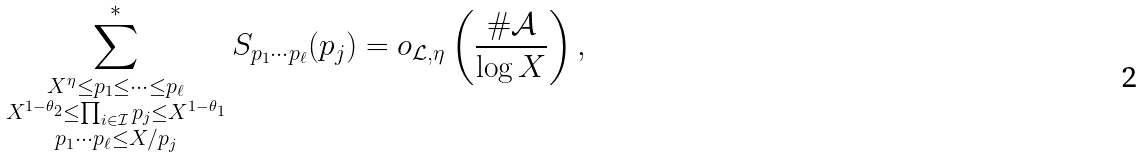<formula> <loc_0><loc_0><loc_500><loc_500>\sum _ { \substack { X ^ { \eta } \leq p _ { 1 } \leq \dots \leq p _ { \ell } \\ X ^ { 1 - \theta _ { 2 } } \leq \prod _ { i \in \mathcal { I } } p _ { j } \leq X ^ { 1 - \theta _ { 1 } } \\ p _ { 1 } \cdots p _ { \ell } \leq X / p _ { j } } } ^ { * } S _ { p _ { 1 } \cdots p _ { \ell } } ( p _ { j } ) = o _ { \mathcal { L } , \eta } \left ( \frac { \# \mathcal { A } } { \log { X } } \right ) ,</formula> 